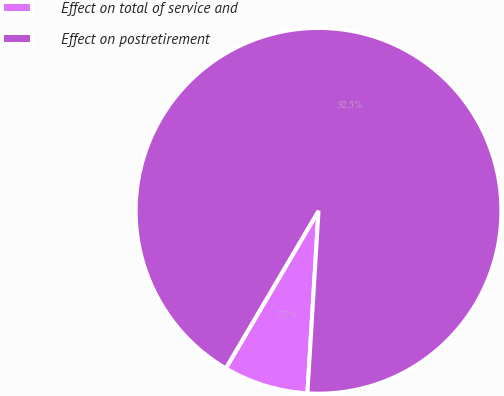<chart> <loc_0><loc_0><loc_500><loc_500><pie_chart><fcel>Effect on total of service and<fcel>Effect on postretirement<nl><fcel>7.5%<fcel>92.5%<nl></chart> 